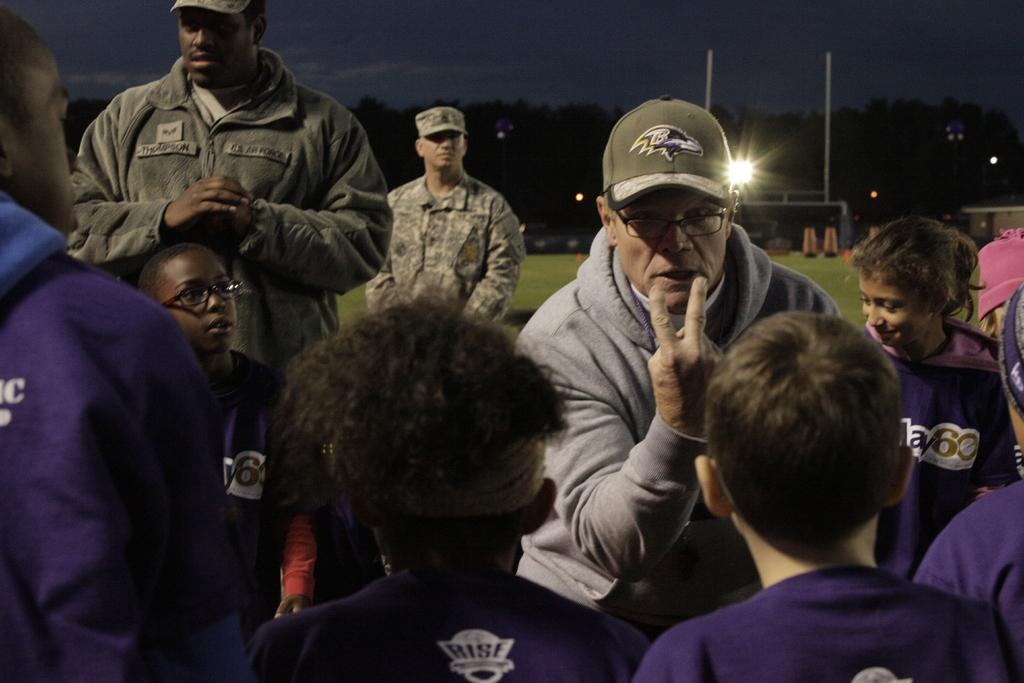How many people are in the image? There is a group of people in the image. What type of terrain is visible in the image? There is grass visible in the image. What structures can be seen in the image? There are poles, lights, a fence, a building, and a group of trees in the image. What part of the natural environment is visible in the image? The sky is visible in the image. Can you see a frog sleeping on the grass in the image? There is no frog or indication of sleep in the image; it features a group of people and various structures and natural elements. 